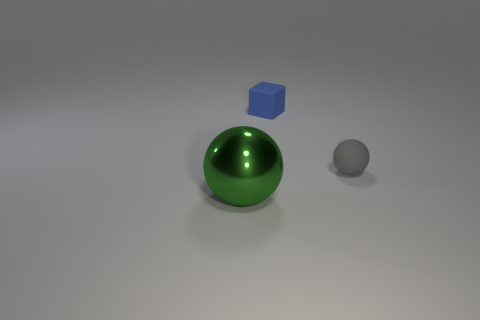What shape is the tiny matte object left of the matte object that is to the right of the tiny matte thing on the left side of the small gray matte thing?
Your answer should be very brief. Cube. Do the green object and the gray thing have the same shape?
Provide a short and direct response. Yes. What shape is the rubber object on the right side of the tiny object that is on the left side of the gray ball?
Your answer should be compact. Sphere. Are any large green objects visible?
Make the answer very short. Yes. There is a sphere that is on the left side of the rubber thing to the right of the tiny blue matte cube; what number of objects are on the right side of it?
Offer a terse response. 2. Do the green metallic thing and the rubber thing on the left side of the tiny gray matte object have the same shape?
Offer a terse response. No. Are there more tiny red rubber cubes than blue matte things?
Your response must be concise. No. Is there any other thing that is the same size as the blue thing?
Provide a succinct answer. Yes. There is a tiny object that is behind the rubber ball; does it have the same shape as the gray rubber thing?
Give a very brief answer. No. Is the number of blue blocks that are right of the small gray matte thing greater than the number of big purple cubes?
Make the answer very short. No. 